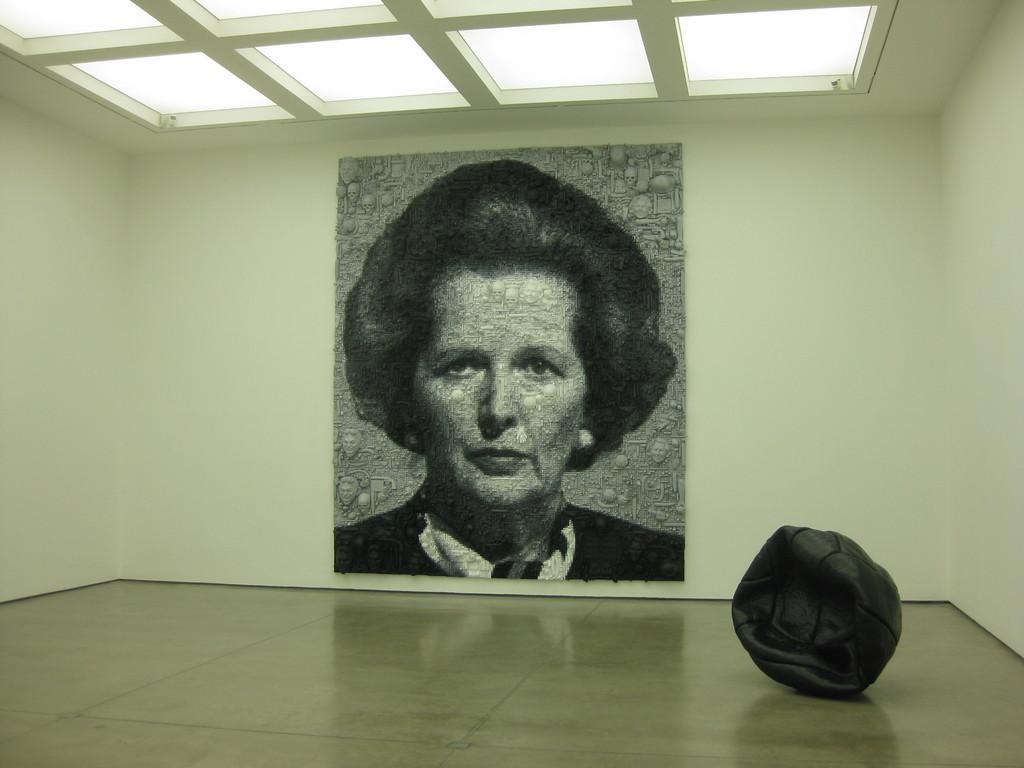In one or two sentences, can you explain what this image depicts? At the bottom of the image there is a floor. On the right side of the image on the floor there is a black color object. And on the wall there is a frame with a lady image. At the top of the image there are windows. 